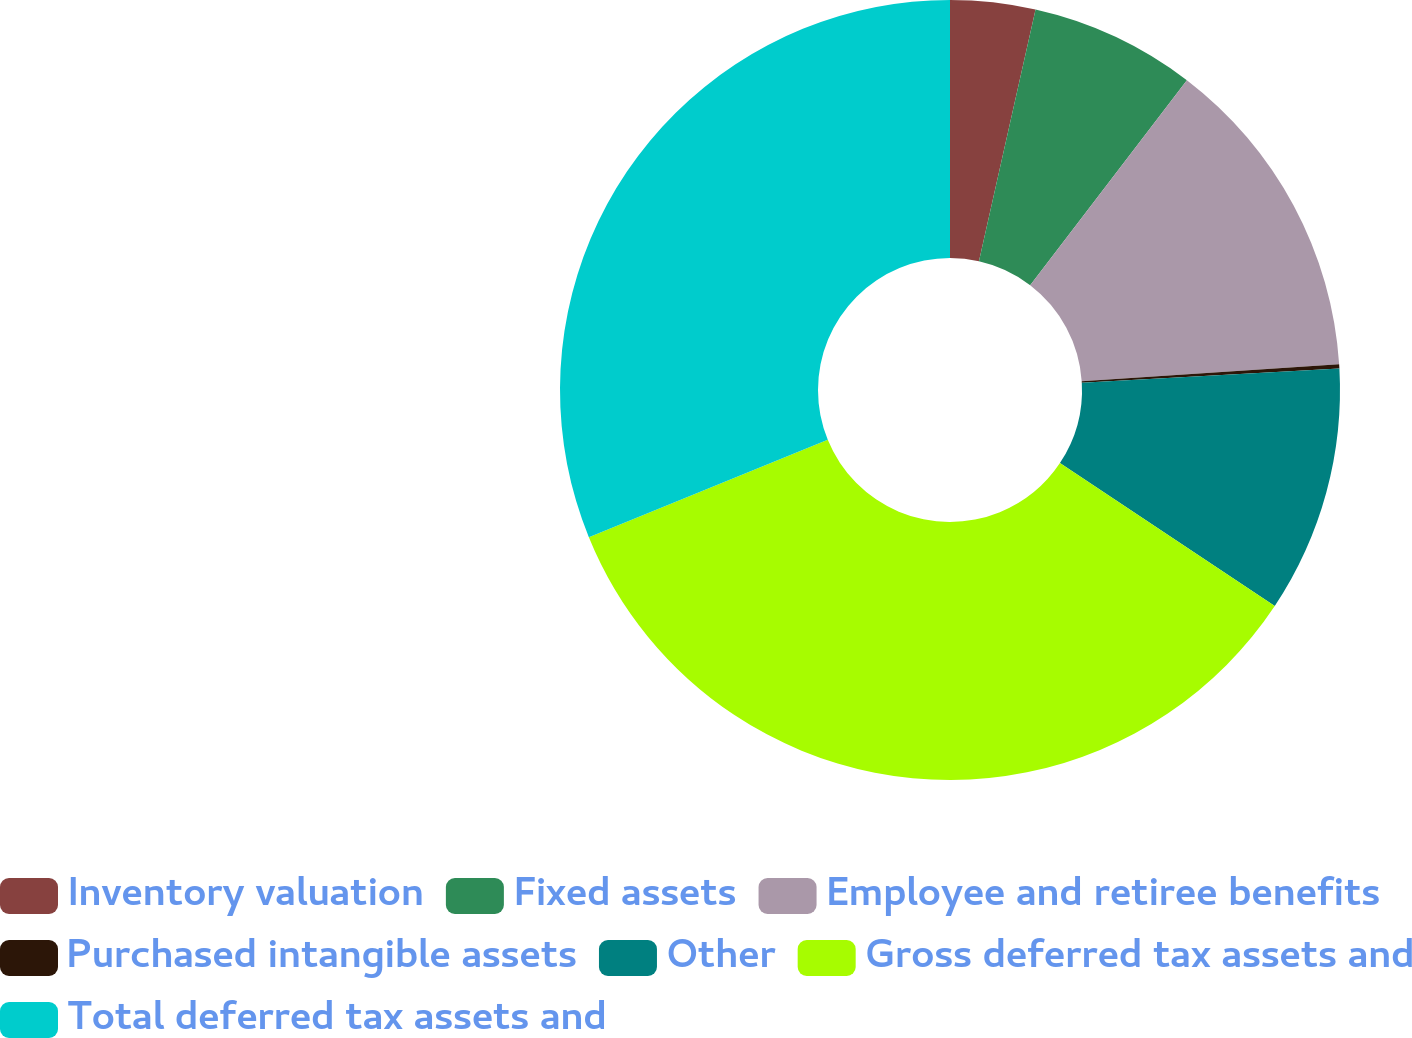Convert chart. <chart><loc_0><loc_0><loc_500><loc_500><pie_chart><fcel>Inventory valuation<fcel>Fixed assets<fcel>Employee and retiree benefits<fcel>Purchased intangible assets<fcel>Other<fcel>Gross deferred tax assets and<fcel>Total deferred tax assets and<nl><fcel>3.52%<fcel>6.87%<fcel>13.56%<fcel>0.17%<fcel>10.22%<fcel>34.5%<fcel>31.16%<nl></chart> 